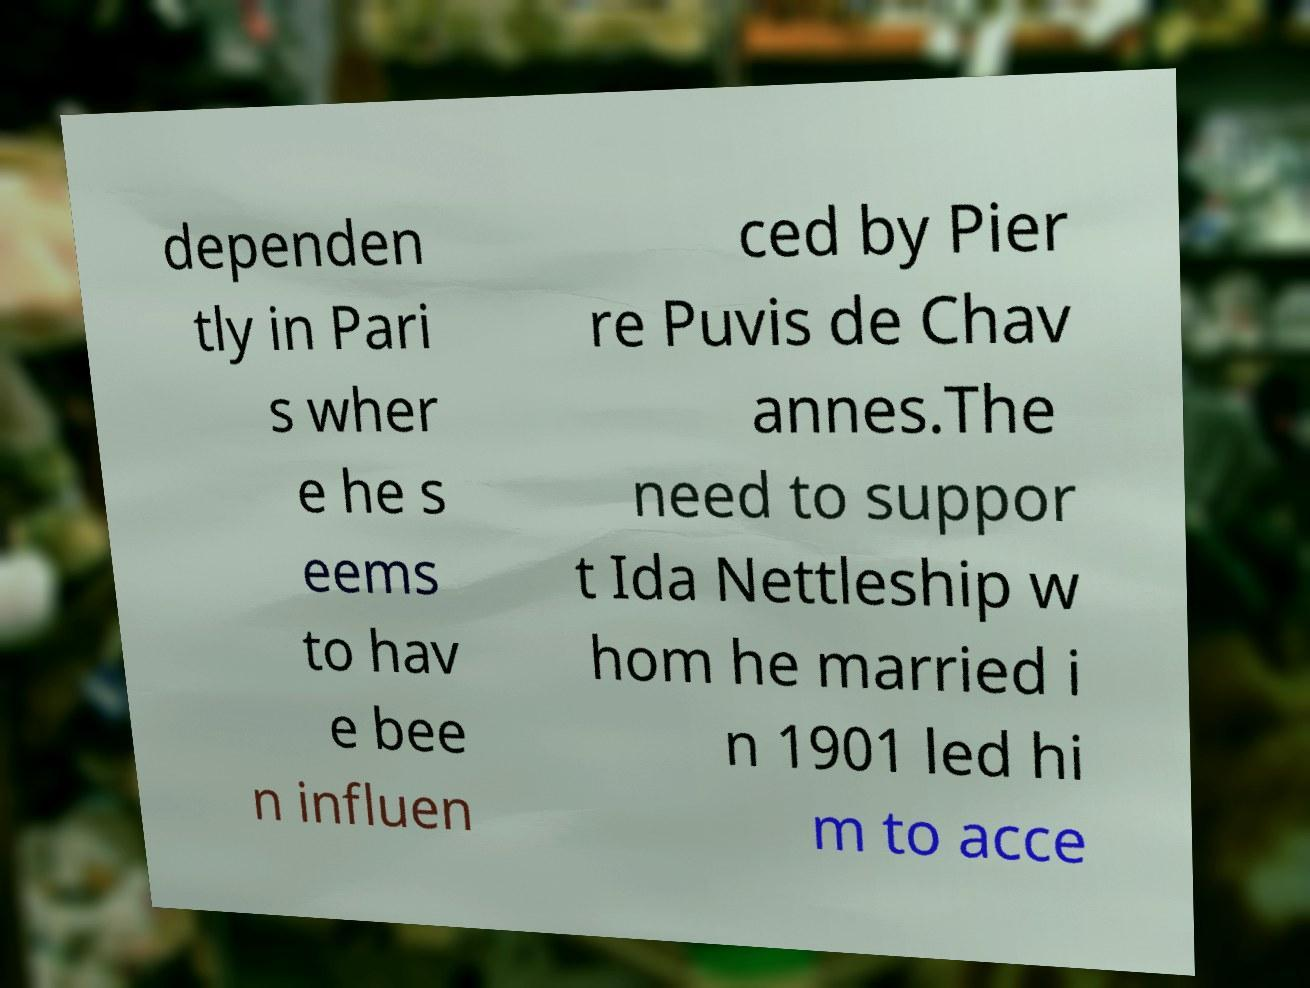Can you read and provide the text displayed in the image?This photo seems to have some interesting text. Can you extract and type it out for me? dependen tly in Pari s wher e he s eems to hav e bee n influen ced by Pier re Puvis de Chav annes.The need to suppor t Ida Nettleship w hom he married i n 1901 led hi m to acce 